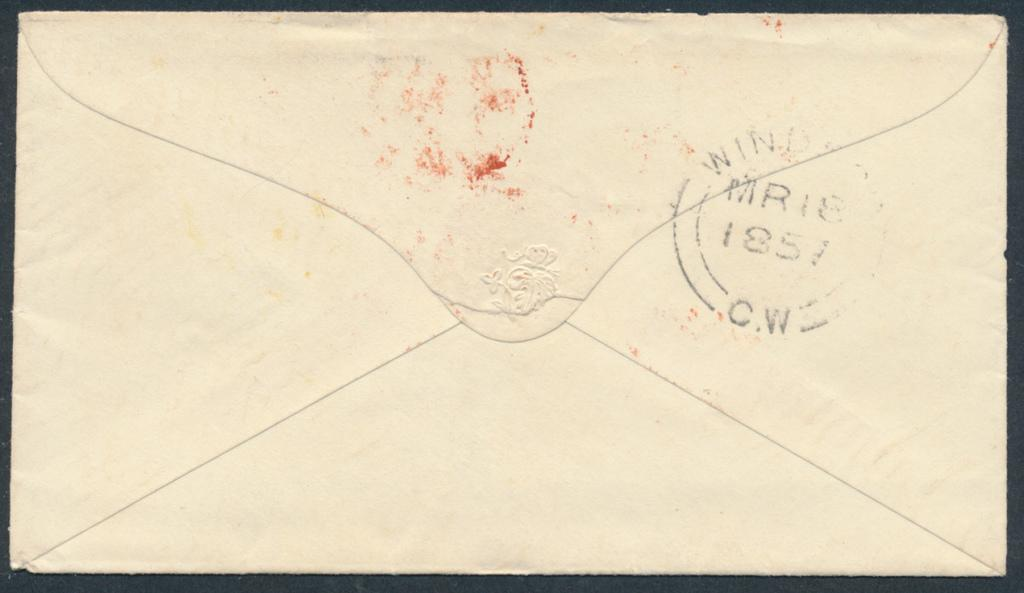Provide a one-sentence caption for the provided image. The back of an enveloped has a stamp, dated 1857. 